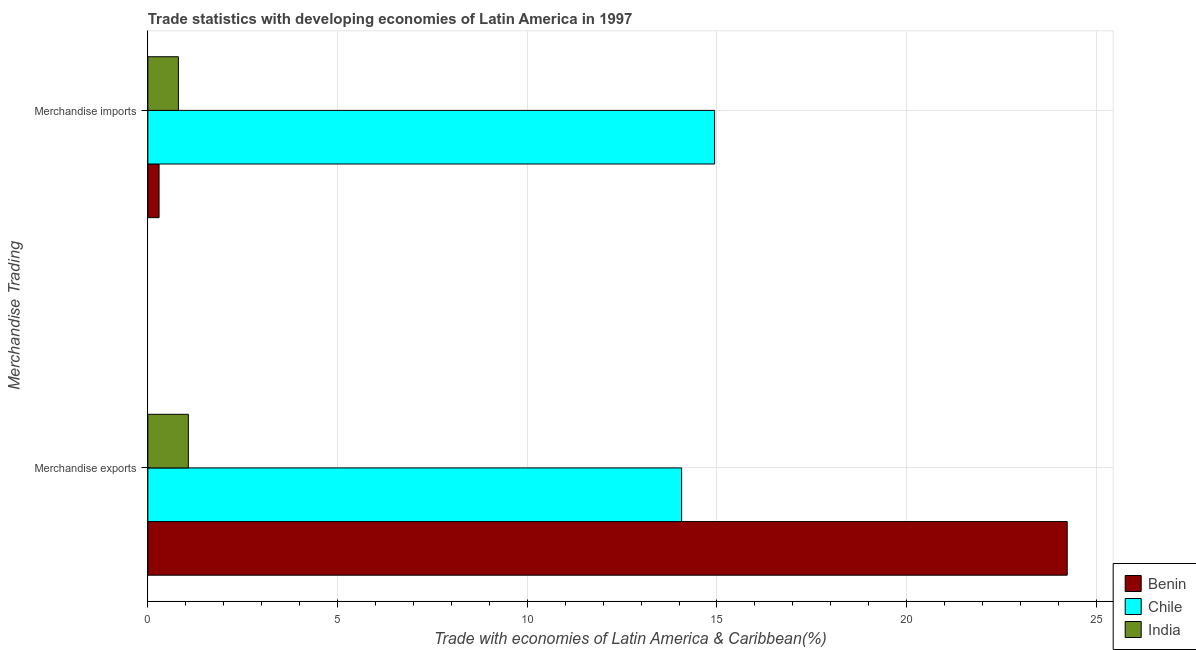Are the number of bars on each tick of the Y-axis equal?
Your response must be concise. Yes. What is the label of the 2nd group of bars from the top?
Your answer should be very brief. Merchandise exports. What is the merchandise exports in Benin?
Provide a short and direct response. 24.23. Across all countries, what is the maximum merchandise imports?
Ensure brevity in your answer.  14.94. Across all countries, what is the minimum merchandise imports?
Offer a terse response. 0.3. In which country was the merchandise exports maximum?
Your answer should be compact. Benin. In which country was the merchandise exports minimum?
Give a very brief answer. India. What is the total merchandise exports in the graph?
Provide a short and direct response. 39.37. What is the difference between the merchandise imports in Benin and that in Chile?
Make the answer very short. -14.64. What is the difference between the merchandise exports in Benin and the merchandise imports in Chile?
Your answer should be very brief. 9.29. What is the average merchandise imports per country?
Offer a terse response. 5.35. What is the difference between the merchandise exports and merchandise imports in Chile?
Your answer should be very brief. -0.87. What is the ratio of the merchandise exports in Benin to that in Chile?
Provide a succinct answer. 1.72. What does the 3rd bar from the top in Merchandise imports represents?
Keep it short and to the point. Benin. What does the 1st bar from the bottom in Merchandise exports represents?
Give a very brief answer. Benin. Are all the bars in the graph horizontal?
Ensure brevity in your answer.  Yes. What is the difference between two consecutive major ticks on the X-axis?
Your answer should be very brief. 5. Does the graph contain grids?
Make the answer very short. Yes. What is the title of the graph?
Keep it short and to the point. Trade statistics with developing economies of Latin America in 1997. What is the label or title of the X-axis?
Offer a very short reply. Trade with economies of Latin America & Caribbean(%). What is the label or title of the Y-axis?
Give a very brief answer. Merchandise Trading. What is the Trade with economies of Latin America & Caribbean(%) in Benin in Merchandise exports?
Keep it short and to the point. 24.23. What is the Trade with economies of Latin America & Caribbean(%) in Chile in Merchandise exports?
Keep it short and to the point. 14.07. What is the Trade with economies of Latin America & Caribbean(%) in India in Merchandise exports?
Offer a terse response. 1.07. What is the Trade with economies of Latin America & Caribbean(%) of Benin in Merchandise imports?
Ensure brevity in your answer.  0.3. What is the Trade with economies of Latin America & Caribbean(%) in Chile in Merchandise imports?
Your response must be concise. 14.94. What is the Trade with economies of Latin America & Caribbean(%) of India in Merchandise imports?
Provide a succinct answer. 0.8. Across all Merchandise Trading, what is the maximum Trade with economies of Latin America & Caribbean(%) in Benin?
Make the answer very short. 24.23. Across all Merchandise Trading, what is the maximum Trade with economies of Latin America & Caribbean(%) of Chile?
Offer a very short reply. 14.94. Across all Merchandise Trading, what is the maximum Trade with economies of Latin America & Caribbean(%) of India?
Offer a terse response. 1.07. Across all Merchandise Trading, what is the minimum Trade with economies of Latin America & Caribbean(%) of Benin?
Offer a very short reply. 0.3. Across all Merchandise Trading, what is the minimum Trade with economies of Latin America & Caribbean(%) in Chile?
Make the answer very short. 14.07. Across all Merchandise Trading, what is the minimum Trade with economies of Latin America & Caribbean(%) of India?
Provide a succinct answer. 0.8. What is the total Trade with economies of Latin America & Caribbean(%) in Benin in the graph?
Provide a succinct answer. 24.53. What is the total Trade with economies of Latin America & Caribbean(%) in Chile in the graph?
Provide a short and direct response. 29.01. What is the total Trade with economies of Latin America & Caribbean(%) of India in the graph?
Make the answer very short. 1.87. What is the difference between the Trade with economies of Latin America & Caribbean(%) of Benin in Merchandise exports and that in Merchandise imports?
Provide a short and direct response. 23.94. What is the difference between the Trade with economies of Latin America & Caribbean(%) of Chile in Merchandise exports and that in Merchandise imports?
Your answer should be very brief. -0.87. What is the difference between the Trade with economies of Latin America & Caribbean(%) in India in Merchandise exports and that in Merchandise imports?
Make the answer very short. 0.26. What is the difference between the Trade with economies of Latin America & Caribbean(%) of Benin in Merchandise exports and the Trade with economies of Latin America & Caribbean(%) of Chile in Merchandise imports?
Your answer should be very brief. 9.29. What is the difference between the Trade with economies of Latin America & Caribbean(%) in Benin in Merchandise exports and the Trade with economies of Latin America & Caribbean(%) in India in Merchandise imports?
Offer a very short reply. 23.43. What is the difference between the Trade with economies of Latin America & Caribbean(%) of Chile in Merchandise exports and the Trade with economies of Latin America & Caribbean(%) of India in Merchandise imports?
Provide a short and direct response. 13.26. What is the average Trade with economies of Latin America & Caribbean(%) in Benin per Merchandise Trading?
Your answer should be compact. 12.26. What is the average Trade with economies of Latin America & Caribbean(%) in Chile per Merchandise Trading?
Your response must be concise. 14.5. What is the average Trade with economies of Latin America & Caribbean(%) of India per Merchandise Trading?
Your answer should be very brief. 0.94. What is the difference between the Trade with economies of Latin America & Caribbean(%) in Benin and Trade with economies of Latin America & Caribbean(%) in Chile in Merchandise exports?
Your response must be concise. 10.16. What is the difference between the Trade with economies of Latin America & Caribbean(%) of Benin and Trade with economies of Latin America & Caribbean(%) of India in Merchandise exports?
Keep it short and to the point. 23.16. What is the difference between the Trade with economies of Latin America & Caribbean(%) in Chile and Trade with economies of Latin America & Caribbean(%) in India in Merchandise exports?
Offer a terse response. 13. What is the difference between the Trade with economies of Latin America & Caribbean(%) in Benin and Trade with economies of Latin America & Caribbean(%) in Chile in Merchandise imports?
Offer a very short reply. -14.64. What is the difference between the Trade with economies of Latin America & Caribbean(%) in Benin and Trade with economies of Latin America & Caribbean(%) in India in Merchandise imports?
Make the answer very short. -0.51. What is the difference between the Trade with economies of Latin America & Caribbean(%) of Chile and Trade with economies of Latin America & Caribbean(%) of India in Merchandise imports?
Keep it short and to the point. 14.13. What is the ratio of the Trade with economies of Latin America & Caribbean(%) in Benin in Merchandise exports to that in Merchandise imports?
Offer a terse response. 82.08. What is the ratio of the Trade with economies of Latin America & Caribbean(%) of Chile in Merchandise exports to that in Merchandise imports?
Your response must be concise. 0.94. What is the ratio of the Trade with economies of Latin America & Caribbean(%) in India in Merchandise exports to that in Merchandise imports?
Provide a short and direct response. 1.33. What is the difference between the highest and the second highest Trade with economies of Latin America & Caribbean(%) of Benin?
Your answer should be very brief. 23.94. What is the difference between the highest and the second highest Trade with economies of Latin America & Caribbean(%) in Chile?
Your answer should be very brief. 0.87. What is the difference between the highest and the second highest Trade with economies of Latin America & Caribbean(%) of India?
Ensure brevity in your answer.  0.26. What is the difference between the highest and the lowest Trade with economies of Latin America & Caribbean(%) in Benin?
Provide a short and direct response. 23.94. What is the difference between the highest and the lowest Trade with economies of Latin America & Caribbean(%) of Chile?
Keep it short and to the point. 0.87. What is the difference between the highest and the lowest Trade with economies of Latin America & Caribbean(%) of India?
Give a very brief answer. 0.26. 